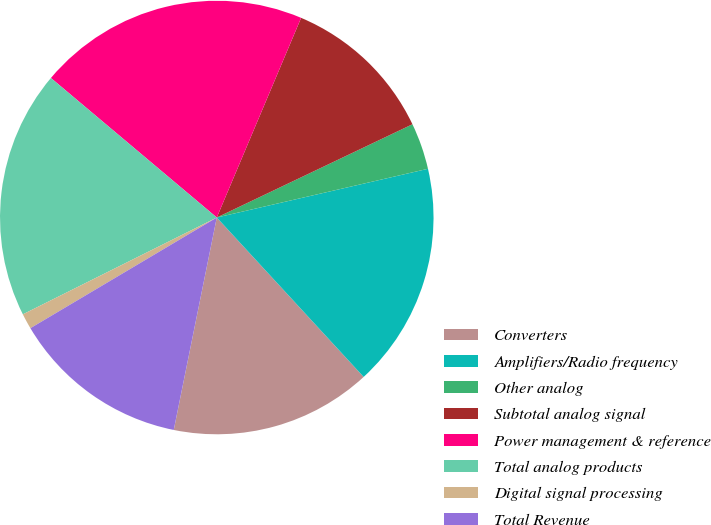<chart> <loc_0><loc_0><loc_500><loc_500><pie_chart><fcel>Converters<fcel>Amplifiers/Radio frequency<fcel>Other analog<fcel>Subtotal analog signal<fcel>Power management & reference<fcel>Total analog products<fcel>Digital signal processing<fcel>Total Revenue<nl><fcel>15.03%<fcel>16.76%<fcel>3.47%<fcel>11.56%<fcel>20.23%<fcel>18.5%<fcel>1.16%<fcel>13.29%<nl></chart> 